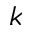Convert formula to latex. <formula><loc_0><loc_0><loc_500><loc_500>k</formula> 